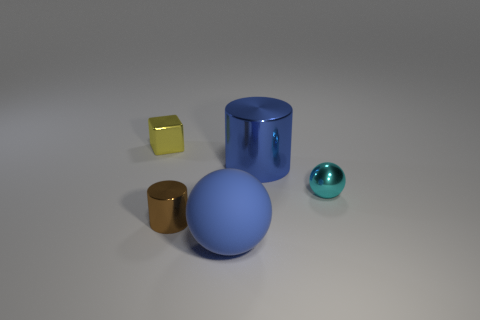Comparing the sizes, can you estimate the ratio of the cylinder's height to the blue sphere's diameter? Estimating visually, the cylinder's height seems to be approximately twice the diameter of the blue sphere, suggesting a 2:1 ratio. 